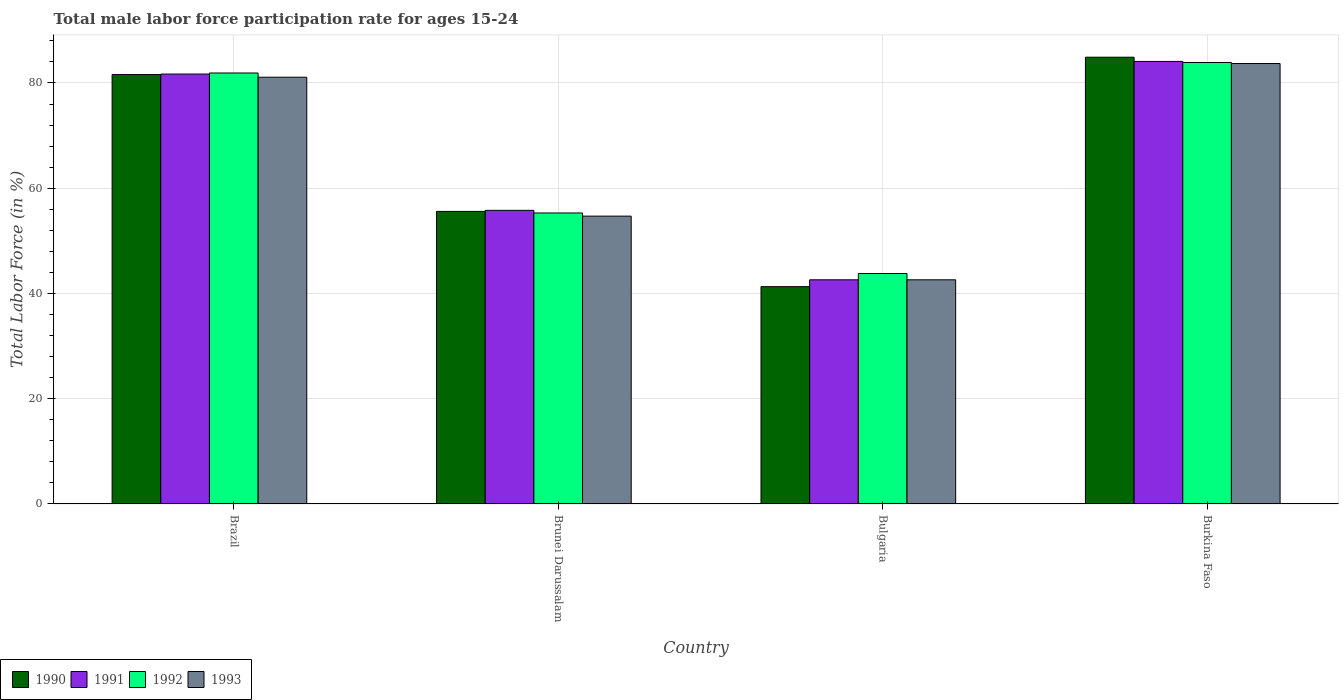How many groups of bars are there?
Provide a succinct answer. 4. How many bars are there on the 3rd tick from the left?
Your response must be concise. 4. What is the label of the 3rd group of bars from the left?
Keep it short and to the point. Bulgaria. What is the male labor force participation rate in 1990 in Brunei Darussalam?
Keep it short and to the point. 55.6. Across all countries, what is the maximum male labor force participation rate in 1992?
Offer a very short reply. 83.9. Across all countries, what is the minimum male labor force participation rate in 1992?
Your response must be concise. 43.8. In which country was the male labor force participation rate in 1990 maximum?
Ensure brevity in your answer.  Burkina Faso. In which country was the male labor force participation rate in 1993 minimum?
Provide a short and direct response. Bulgaria. What is the total male labor force participation rate in 1993 in the graph?
Give a very brief answer. 262.1. What is the difference between the male labor force participation rate in 1991 in Brazil and that in Burkina Faso?
Offer a very short reply. -2.4. What is the difference between the male labor force participation rate in 1991 in Brunei Darussalam and the male labor force participation rate in 1993 in Bulgaria?
Keep it short and to the point. 13.2. What is the average male labor force participation rate in 1991 per country?
Ensure brevity in your answer.  66.05. What is the difference between the male labor force participation rate of/in 1992 and male labor force participation rate of/in 1993 in Bulgaria?
Offer a very short reply. 1.2. What is the ratio of the male labor force participation rate in 1990 in Brazil to that in Brunei Darussalam?
Your response must be concise. 1.47. Is the male labor force participation rate in 1993 in Brazil less than that in Brunei Darussalam?
Keep it short and to the point. No. What is the difference between the highest and the second highest male labor force participation rate in 1993?
Make the answer very short. -2.6. What is the difference between the highest and the lowest male labor force participation rate in 1993?
Make the answer very short. 41.1. In how many countries, is the male labor force participation rate in 1991 greater than the average male labor force participation rate in 1991 taken over all countries?
Provide a succinct answer. 2. Is the sum of the male labor force participation rate in 1990 in Bulgaria and Burkina Faso greater than the maximum male labor force participation rate in 1991 across all countries?
Provide a short and direct response. Yes. Is it the case that in every country, the sum of the male labor force participation rate in 1992 and male labor force participation rate in 1993 is greater than the sum of male labor force participation rate in 1991 and male labor force participation rate in 1990?
Offer a terse response. No. What does the 1st bar from the left in Bulgaria represents?
Offer a terse response. 1990. What does the 1st bar from the right in Burkina Faso represents?
Offer a terse response. 1993. Is it the case that in every country, the sum of the male labor force participation rate in 1992 and male labor force participation rate in 1990 is greater than the male labor force participation rate in 1991?
Offer a terse response. Yes. How many bars are there?
Provide a succinct answer. 16. Are all the bars in the graph horizontal?
Provide a succinct answer. No. How many countries are there in the graph?
Your response must be concise. 4. What is the difference between two consecutive major ticks on the Y-axis?
Make the answer very short. 20. Does the graph contain any zero values?
Offer a terse response. No. Where does the legend appear in the graph?
Your response must be concise. Bottom left. What is the title of the graph?
Make the answer very short. Total male labor force participation rate for ages 15-24. Does "1989" appear as one of the legend labels in the graph?
Your response must be concise. No. What is the label or title of the Y-axis?
Your answer should be very brief. Total Labor Force (in %). What is the Total Labor Force (in %) of 1990 in Brazil?
Offer a very short reply. 81.6. What is the Total Labor Force (in %) of 1991 in Brazil?
Ensure brevity in your answer.  81.7. What is the Total Labor Force (in %) of 1992 in Brazil?
Your response must be concise. 81.9. What is the Total Labor Force (in %) in 1993 in Brazil?
Make the answer very short. 81.1. What is the Total Labor Force (in %) of 1990 in Brunei Darussalam?
Keep it short and to the point. 55.6. What is the Total Labor Force (in %) of 1991 in Brunei Darussalam?
Your answer should be very brief. 55.8. What is the Total Labor Force (in %) in 1992 in Brunei Darussalam?
Your answer should be very brief. 55.3. What is the Total Labor Force (in %) of 1993 in Brunei Darussalam?
Your answer should be compact. 54.7. What is the Total Labor Force (in %) of 1990 in Bulgaria?
Offer a terse response. 41.3. What is the Total Labor Force (in %) in 1991 in Bulgaria?
Provide a short and direct response. 42.6. What is the Total Labor Force (in %) in 1992 in Bulgaria?
Your answer should be compact. 43.8. What is the Total Labor Force (in %) in 1993 in Bulgaria?
Your answer should be very brief. 42.6. What is the Total Labor Force (in %) of 1990 in Burkina Faso?
Ensure brevity in your answer.  84.9. What is the Total Labor Force (in %) of 1991 in Burkina Faso?
Offer a very short reply. 84.1. What is the Total Labor Force (in %) in 1992 in Burkina Faso?
Provide a short and direct response. 83.9. What is the Total Labor Force (in %) in 1993 in Burkina Faso?
Ensure brevity in your answer.  83.7. Across all countries, what is the maximum Total Labor Force (in %) of 1990?
Provide a short and direct response. 84.9. Across all countries, what is the maximum Total Labor Force (in %) of 1991?
Keep it short and to the point. 84.1. Across all countries, what is the maximum Total Labor Force (in %) of 1992?
Your answer should be very brief. 83.9. Across all countries, what is the maximum Total Labor Force (in %) in 1993?
Provide a short and direct response. 83.7. Across all countries, what is the minimum Total Labor Force (in %) of 1990?
Keep it short and to the point. 41.3. Across all countries, what is the minimum Total Labor Force (in %) of 1991?
Offer a very short reply. 42.6. Across all countries, what is the minimum Total Labor Force (in %) in 1992?
Keep it short and to the point. 43.8. Across all countries, what is the minimum Total Labor Force (in %) of 1993?
Make the answer very short. 42.6. What is the total Total Labor Force (in %) in 1990 in the graph?
Your response must be concise. 263.4. What is the total Total Labor Force (in %) of 1991 in the graph?
Keep it short and to the point. 264.2. What is the total Total Labor Force (in %) of 1992 in the graph?
Your response must be concise. 264.9. What is the total Total Labor Force (in %) in 1993 in the graph?
Your answer should be very brief. 262.1. What is the difference between the Total Labor Force (in %) in 1990 in Brazil and that in Brunei Darussalam?
Offer a terse response. 26. What is the difference between the Total Labor Force (in %) in 1991 in Brazil and that in Brunei Darussalam?
Your response must be concise. 25.9. What is the difference between the Total Labor Force (in %) in 1992 in Brazil and that in Brunei Darussalam?
Keep it short and to the point. 26.6. What is the difference between the Total Labor Force (in %) in 1993 in Brazil and that in Brunei Darussalam?
Provide a short and direct response. 26.4. What is the difference between the Total Labor Force (in %) of 1990 in Brazil and that in Bulgaria?
Offer a very short reply. 40.3. What is the difference between the Total Labor Force (in %) of 1991 in Brazil and that in Bulgaria?
Ensure brevity in your answer.  39.1. What is the difference between the Total Labor Force (in %) in 1992 in Brazil and that in Bulgaria?
Offer a terse response. 38.1. What is the difference between the Total Labor Force (in %) in 1993 in Brazil and that in Bulgaria?
Offer a very short reply. 38.5. What is the difference between the Total Labor Force (in %) in 1990 in Brazil and that in Burkina Faso?
Make the answer very short. -3.3. What is the difference between the Total Labor Force (in %) in 1992 in Brazil and that in Burkina Faso?
Your answer should be very brief. -2. What is the difference between the Total Labor Force (in %) of 1993 in Brazil and that in Burkina Faso?
Your response must be concise. -2.6. What is the difference between the Total Labor Force (in %) of 1990 in Brunei Darussalam and that in Bulgaria?
Give a very brief answer. 14.3. What is the difference between the Total Labor Force (in %) of 1991 in Brunei Darussalam and that in Bulgaria?
Give a very brief answer. 13.2. What is the difference between the Total Labor Force (in %) in 1992 in Brunei Darussalam and that in Bulgaria?
Ensure brevity in your answer.  11.5. What is the difference between the Total Labor Force (in %) in 1993 in Brunei Darussalam and that in Bulgaria?
Your response must be concise. 12.1. What is the difference between the Total Labor Force (in %) in 1990 in Brunei Darussalam and that in Burkina Faso?
Make the answer very short. -29.3. What is the difference between the Total Labor Force (in %) in 1991 in Brunei Darussalam and that in Burkina Faso?
Your response must be concise. -28.3. What is the difference between the Total Labor Force (in %) in 1992 in Brunei Darussalam and that in Burkina Faso?
Your answer should be very brief. -28.6. What is the difference between the Total Labor Force (in %) of 1993 in Brunei Darussalam and that in Burkina Faso?
Provide a short and direct response. -29. What is the difference between the Total Labor Force (in %) of 1990 in Bulgaria and that in Burkina Faso?
Make the answer very short. -43.6. What is the difference between the Total Labor Force (in %) in 1991 in Bulgaria and that in Burkina Faso?
Provide a short and direct response. -41.5. What is the difference between the Total Labor Force (in %) in 1992 in Bulgaria and that in Burkina Faso?
Your answer should be compact. -40.1. What is the difference between the Total Labor Force (in %) of 1993 in Bulgaria and that in Burkina Faso?
Give a very brief answer. -41.1. What is the difference between the Total Labor Force (in %) of 1990 in Brazil and the Total Labor Force (in %) of 1991 in Brunei Darussalam?
Provide a short and direct response. 25.8. What is the difference between the Total Labor Force (in %) of 1990 in Brazil and the Total Labor Force (in %) of 1992 in Brunei Darussalam?
Your answer should be very brief. 26.3. What is the difference between the Total Labor Force (in %) of 1990 in Brazil and the Total Labor Force (in %) of 1993 in Brunei Darussalam?
Make the answer very short. 26.9. What is the difference between the Total Labor Force (in %) of 1991 in Brazil and the Total Labor Force (in %) of 1992 in Brunei Darussalam?
Offer a very short reply. 26.4. What is the difference between the Total Labor Force (in %) of 1991 in Brazil and the Total Labor Force (in %) of 1993 in Brunei Darussalam?
Your answer should be very brief. 27. What is the difference between the Total Labor Force (in %) in 1992 in Brazil and the Total Labor Force (in %) in 1993 in Brunei Darussalam?
Keep it short and to the point. 27.2. What is the difference between the Total Labor Force (in %) in 1990 in Brazil and the Total Labor Force (in %) in 1992 in Bulgaria?
Ensure brevity in your answer.  37.8. What is the difference between the Total Labor Force (in %) of 1991 in Brazil and the Total Labor Force (in %) of 1992 in Bulgaria?
Your response must be concise. 37.9. What is the difference between the Total Labor Force (in %) in 1991 in Brazil and the Total Labor Force (in %) in 1993 in Bulgaria?
Your answer should be compact. 39.1. What is the difference between the Total Labor Force (in %) of 1992 in Brazil and the Total Labor Force (in %) of 1993 in Bulgaria?
Give a very brief answer. 39.3. What is the difference between the Total Labor Force (in %) in 1990 in Brazil and the Total Labor Force (in %) in 1992 in Burkina Faso?
Your answer should be very brief. -2.3. What is the difference between the Total Labor Force (in %) in 1990 in Brazil and the Total Labor Force (in %) in 1993 in Burkina Faso?
Offer a terse response. -2.1. What is the difference between the Total Labor Force (in %) in 1991 in Brazil and the Total Labor Force (in %) in 1992 in Burkina Faso?
Offer a very short reply. -2.2. What is the difference between the Total Labor Force (in %) of 1991 in Brazil and the Total Labor Force (in %) of 1993 in Burkina Faso?
Your answer should be compact. -2. What is the difference between the Total Labor Force (in %) in 1990 in Brunei Darussalam and the Total Labor Force (in %) in 1991 in Bulgaria?
Make the answer very short. 13. What is the difference between the Total Labor Force (in %) of 1992 in Brunei Darussalam and the Total Labor Force (in %) of 1993 in Bulgaria?
Provide a succinct answer. 12.7. What is the difference between the Total Labor Force (in %) in 1990 in Brunei Darussalam and the Total Labor Force (in %) in 1991 in Burkina Faso?
Provide a short and direct response. -28.5. What is the difference between the Total Labor Force (in %) of 1990 in Brunei Darussalam and the Total Labor Force (in %) of 1992 in Burkina Faso?
Provide a short and direct response. -28.3. What is the difference between the Total Labor Force (in %) of 1990 in Brunei Darussalam and the Total Labor Force (in %) of 1993 in Burkina Faso?
Your answer should be compact. -28.1. What is the difference between the Total Labor Force (in %) in 1991 in Brunei Darussalam and the Total Labor Force (in %) in 1992 in Burkina Faso?
Your answer should be compact. -28.1. What is the difference between the Total Labor Force (in %) of 1991 in Brunei Darussalam and the Total Labor Force (in %) of 1993 in Burkina Faso?
Give a very brief answer. -27.9. What is the difference between the Total Labor Force (in %) of 1992 in Brunei Darussalam and the Total Labor Force (in %) of 1993 in Burkina Faso?
Make the answer very short. -28.4. What is the difference between the Total Labor Force (in %) in 1990 in Bulgaria and the Total Labor Force (in %) in 1991 in Burkina Faso?
Give a very brief answer. -42.8. What is the difference between the Total Labor Force (in %) of 1990 in Bulgaria and the Total Labor Force (in %) of 1992 in Burkina Faso?
Provide a succinct answer. -42.6. What is the difference between the Total Labor Force (in %) in 1990 in Bulgaria and the Total Labor Force (in %) in 1993 in Burkina Faso?
Provide a succinct answer. -42.4. What is the difference between the Total Labor Force (in %) in 1991 in Bulgaria and the Total Labor Force (in %) in 1992 in Burkina Faso?
Ensure brevity in your answer.  -41.3. What is the difference between the Total Labor Force (in %) in 1991 in Bulgaria and the Total Labor Force (in %) in 1993 in Burkina Faso?
Offer a terse response. -41.1. What is the difference between the Total Labor Force (in %) of 1992 in Bulgaria and the Total Labor Force (in %) of 1993 in Burkina Faso?
Your answer should be compact. -39.9. What is the average Total Labor Force (in %) of 1990 per country?
Make the answer very short. 65.85. What is the average Total Labor Force (in %) in 1991 per country?
Offer a very short reply. 66.05. What is the average Total Labor Force (in %) of 1992 per country?
Your answer should be compact. 66.22. What is the average Total Labor Force (in %) in 1993 per country?
Ensure brevity in your answer.  65.53. What is the difference between the Total Labor Force (in %) of 1990 and Total Labor Force (in %) of 1991 in Brunei Darussalam?
Provide a succinct answer. -0.2. What is the difference between the Total Labor Force (in %) in 1991 and Total Labor Force (in %) in 1992 in Brunei Darussalam?
Give a very brief answer. 0.5. What is the difference between the Total Labor Force (in %) of 1991 and Total Labor Force (in %) of 1993 in Brunei Darussalam?
Keep it short and to the point. 1.1. What is the difference between the Total Labor Force (in %) of 1990 and Total Labor Force (in %) of 1992 in Bulgaria?
Offer a very short reply. -2.5. What is the difference between the Total Labor Force (in %) in 1990 and Total Labor Force (in %) in 1993 in Bulgaria?
Keep it short and to the point. -1.3. What is the difference between the Total Labor Force (in %) of 1992 and Total Labor Force (in %) of 1993 in Bulgaria?
Your response must be concise. 1.2. What is the difference between the Total Labor Force (in %) in 1990 and Total Labor Force (in %) in 1991 in Burkina Faso?
Provide a short and direct response. 0.8. What is the difference between the Total Labor Force (in %) of 1990 and Total Labor Force (in %) of 1993 in Burkina Faso?
Offer a terse response. 1.2. What is the difference between the Total Labor Force (in %) in 1991 and Total Labor Force (in %) in 1992 in Burkina Faso?
Give a very brief answer. 0.2. What is the ratio of the Total Labor Force (in %) in 1990 in Brazil to that in Brunei Darussalam?
Keep it short and to the point. 1.47. What is the ratio of the Total Labor Force (in %) in 1991 in Brazil to that in Brunei Darussalam?
Make the answer very short. 1.46. What is the ratio of the Total Labor Force (in %) in 1992 in Brazil to that in Brunei Darussalam?
Ensure brevity in your answer.  1.48. What is the ratio of the Total Labor Force (in %) in 1993 in Brazil to that in Brunei Darussalam?
Make the answer very short. 1.48. What is the ratio of the Total Labor Force (in %) of 1990 in Brazil to that in Bulgaria?
Your answer should be compact. 1.98. What is the ratio of the Total Labor Force (in %) in 1991 in Brazil to that in Bulgaria?
Give a very brief answer. 1.92. What is the ratio of the Total Labor Force (in %) in 1992 in Brazil to that in Bulgaria?
Your answer should be very brief. 1.87. What is the ratio of the Total Labor Force (in %) in 1993 in Brazil to that in Bulgaria?
Your response must be concise. 1.9. What is the ratio of the Total Labor Force (in %) in 1990 in Brazil to that in Burkina Faso?
Offer a very short reply. 0.96. What is the ratio of the Total Labor Force (in %) of 1991 in Brazil to that in Burkina Faso?
Ensure brevity in your answer.  0.97. What is the ratio of the Total Labor Force (in %) in 1992 in Brazil to that in Burkina Faso?
Make the answer very short. 0.98. What is the ratio of the Total Labor Force (in %) in 1993 in Brazil to that in Burkina Faso?
Ensure brevity in your answer.  0.97. What is the ratio of the Total Labor Force (in %) of 1990 in Brunei Darussalam to that in Bulgaria?
Offer a very short reply. 1.35. What is the ratio of the Total Labor Force (in %) of 1991 in Brunei Darussalam to that in Bulgaria?
Offer a very short reply. 1.31. What is the ratio of the Total Labor Force (in %) in 1992 in Brunei Darussalam to that in Bulgaria?
Your answer should be compact. 1.26. What is the ratio of the Total Labor Force (in %) in 1993 in Brunei Darussalam to that in Bulgaria?
Keep it short and to the point. 1.28. What is the ratio of the Total Labor Force (in %) in 1990 in Brunei Darussalam to that in Burkina Faso?
Provide a short and direct response. 0.65. What is the ratio of the Total Labor Force (in %) in 1991 in Brunei Darussalam to that in Burkina Faso?
Provide a succinct answer. 0.66. What is the ratio of the Total Labor Force (in %) in 1992 in Brunei Darussalam to that in Burkina Faso?
Your response must be concise. 0.66. What is the ratio of the Total Labor Force (in %) of 1993 in Brunei Darussalam to that in Burkina Faso?
Offer a very short reply. 0.65. What is the ratio of the Total Labor Force (in %) in 1990 in Bulgaria to that in Burkina Faso?
Give a very brief answer. 0.49. What is the ratio of the Total Labor Force (in %) of 1991 in Bulgaria to that in Burkina Faso?
Offer a very short reply. 0.51. What is the ratio of the Total Labor Force (in %) of 1992 in Bulgaria to that in Burkina Faso?
Your answer should be very brief. 0.52. What is the ratio of the Total Labor Force (in %) of 1993 in Bulgaria to that in Burkina Faso?
Give a very brief answer. 0.51. What is the difference between the highest and the lowest Total Labor Force (in %) in 1990?
Make the answer very short. 43.6. What is the difference between the highest and the lowest Total Labor Force (in %) of 1991?
Keep it short and to the point. 41.5. What is the difference between the highest and the lowest Total Labor Force (in %) in 1992?
Provide a succinct answer. 40.1. What is the difference between the highest and the lowest Total Labor Force (in %) of 1993?
Offer a terse response. 41.1. 